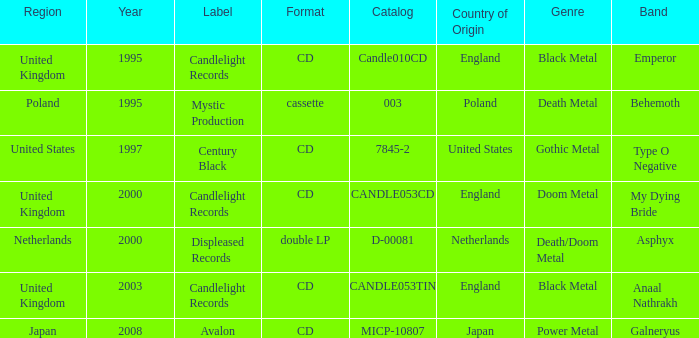What is Candlelight Records format? CD, CD, CD. 